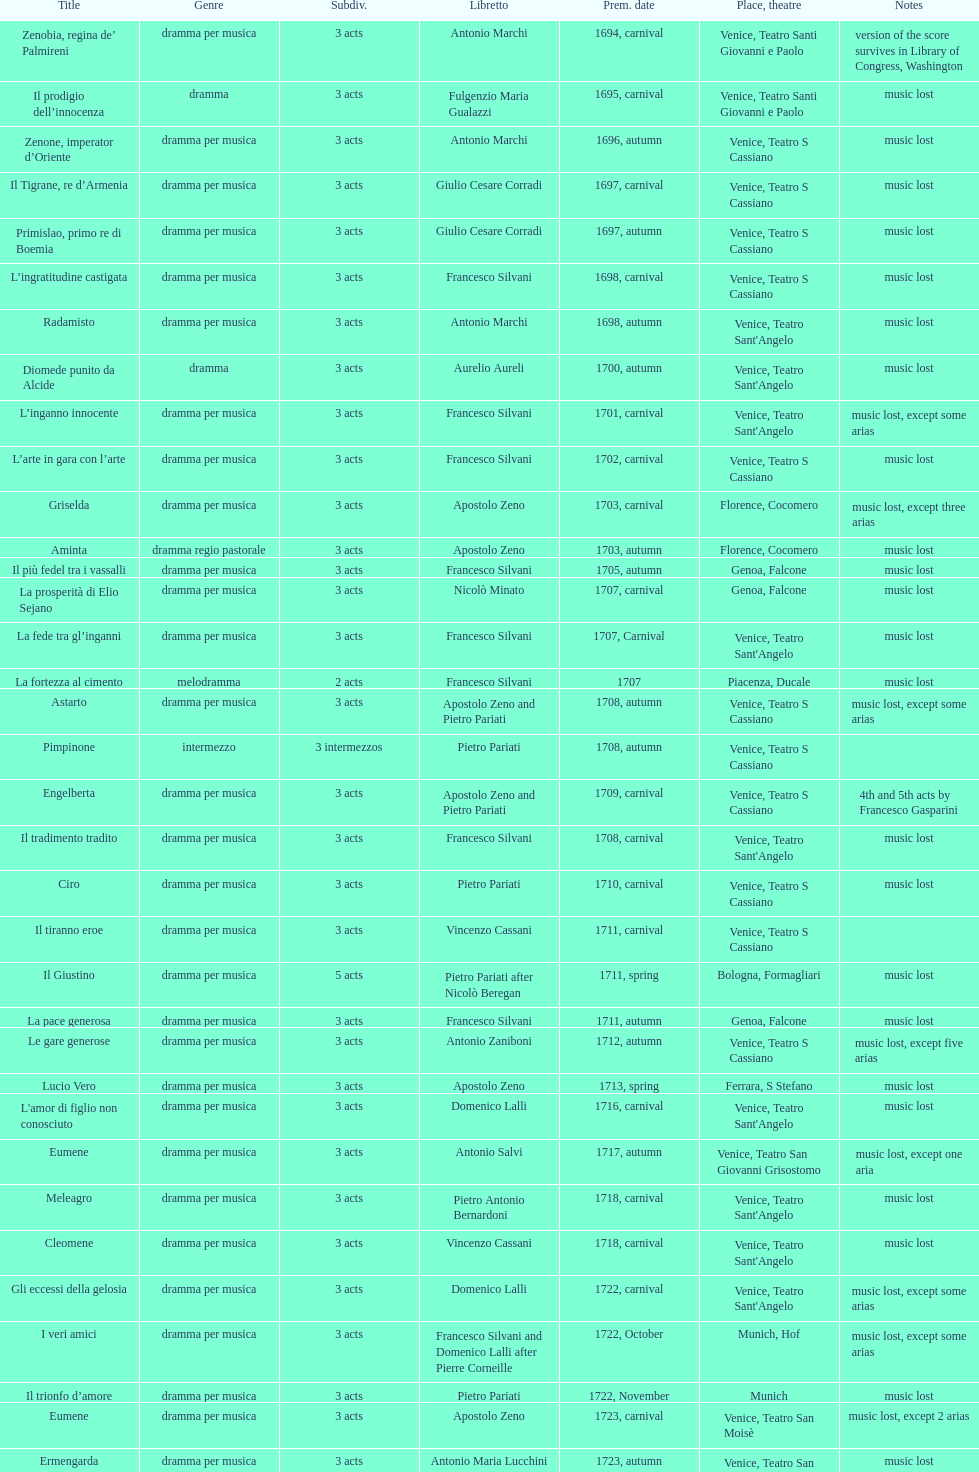What number of acts does il giustino have? 5. 